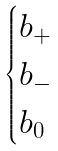Convert formula to latex. <formula><loc_0><loc_0><loc_500><loc_500>\begin{cases} b _ { + } \\ b _ { - } \\ b _ { 0 } \end{cases}</formula> 